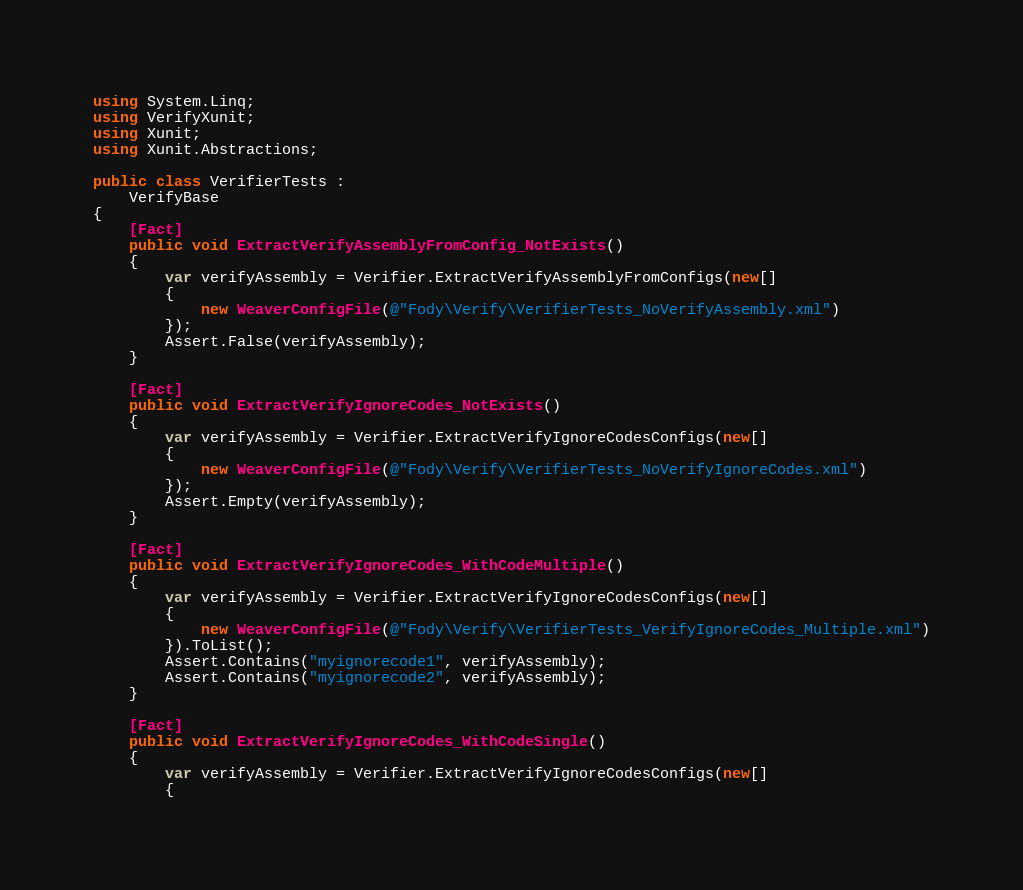<code> <loc_0><loc_0><loc_500><loc_500><_C#_>using System.Linq;
using VerifyXunit;
using Xunit;
using Xunit.Abstractions;

public class VerifierTests :
    VerifyBase
{
    [Fact]
    public void ExtractVerifyAssemblyFromConfig_NotExists()
    {
        var verifyAssembly = Verifier.ExtractVerifyAssemblyFromConfigs(new[]
        {
            new WeaverConfigFile(@"Fody\Verify\VerifierTests_NoVerifyAssembly.xml")
        });
        Assert.False(verifyAssembly);
    }

    [Fact]
    public void ExtractVerifyIgnoreCodes_NotExists()
    {
        var verifyAssembly = Verifier.ExtractVerifyIgnoreCodesConfigs(new[]
        {
            new WeaverConfigFile(@"Fody\Verify\VerifierTests_NoVerifyIgnoreCodes.xml")
        });
        Assert.Empty(verifyAssembly);
    }

    [Fact]
    public void ExtractVerifyIgnoreCodes_WithCodeMultiple()
    {
        var verifyAssembly = Verifier.ExtractVerifyIgnoreCodesConfigs(new[]
        {
            new WeaverConfigFile(@"Fody\Verify\VerifierTests_VerifyIgnoreCodes_Multiple.xml")
        }).ToList();
        Assert.Contains("myignorecode1", verifyAssembly);
        Assert.Contains("myignorecode2", verifyAssembly);
    }

    [Fact]
    public void ExtractVerifyIgnoreCodes_WithCodeSingle()
    {
        var verifyAssembly = Verifier.ExtractVerifyIgnoreCodesConfigs(new[]
        {</code> 